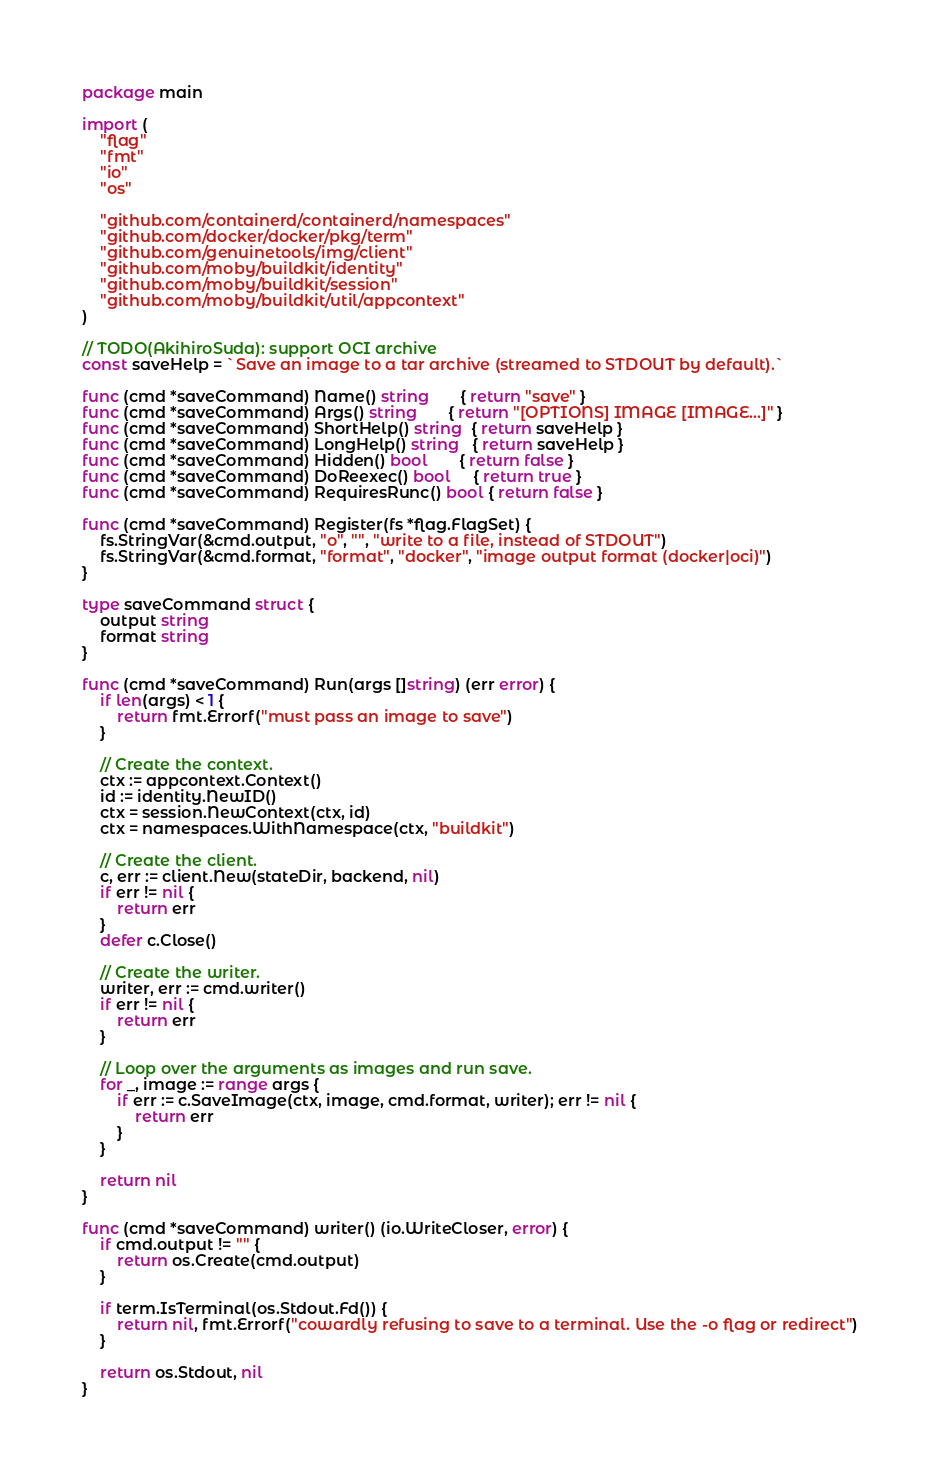<code> <loc_0><loc_0><loc_500><loc_500><_Go_>package main

import (
	"flag"
	"fmt"
	"io"
	"os"

	"github.com/containerd/containerd/namespaces"
	"github.com/docker/docker/pkg/term"
	"github.com/genuinetools/img/client"
	"github.com/moby/buildkit/identity"
	"github.com/moby/buildkit/session"
	"github.com/moby/buildkit/util/appcontext"
)

// TODO(AkihiroSuda): support OCI archive
const saveHelp = `Save an image to a tar archive (streamed to STDOUT by default).`

func (cmd *saveCommand) Name() string       { return "save" }
func (cmd *saveCommand) Args() string       { return "[OPTIONS] IMAGE [IMAGE...]" }
func (cmd *saveCommand) ShortHelp() string  { return saveHelp }
func (cmd *saveCommand) LongHelp() string   { return saveHelp }
func (cmd *saveCommand) Hidden() bool       { return false }
func (cmd *saveCommand) DoReexec() bool     { return true }
func (cmd *saveCommand) RequiresRunc() bool { return false }

func (cmd *saveCommand) Register(fs *flag.FlagSet) {
	fs.StringVar(&cmd.output, "o", "", "write to a file, instead of STDOUT")
	fs.StringVar(&cmd.format, "format", "docker", "image output format (docker|oci)")
}

type saveCommand struct {
	output string
	format string
}

func (cmd *saveCommand) Run(args []string) (err error) {
	if len(args) < 1 {
		return fmt.Errorf("must pass an image to save")
	}

	// Create the context.
	ctx := appcontext.Context()
	id := identity.NewID()
	ctx = session.NewContext(ctx, id)
	ctx = namespaces.WithNamespace(ctx, "buildkit")

	// Create the client.
	c, err := client.New(stateDir, backend, nil)
	if err != nil {
		return err
	}
	defer c.Close()

	// Create the writer.
	writer, err := cmd.writer()
	if err != nil {
		return err
	}

	// Loop over the arguments as images and run save.
	for _, image := range args {
		if err := c.SaveImage(ctx, image, cmd.format, writer); err != nil {
			return err
		}
	}

	return nil
}

func (cmd *saveCommand) writer() (io.WriteCloser, error) {
	if cmd.output != "" {
		return os.Create(cmd.output)
	}

	if term.IsTerminal(os.Stdout.Fd()) {
		return nil, fmt.Errorf("cowardly refusing to save to a terminal. Use the -o flag or redirect")
	}

	return os.Stdout, nil
}
</code> 